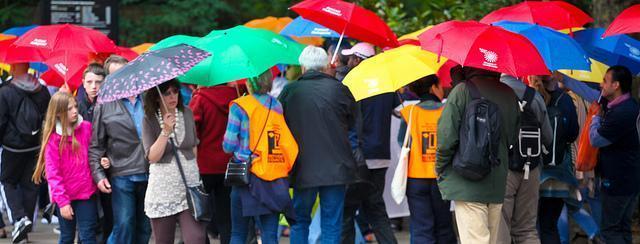How many umbrellas can you see?
Give a very brief answer. 8. How many people are there?
Give a very brief answer. 12. How many backpacks are there?
Give a very brief answer. 2. How many oranges can you see?
Give a very brief answer. 0. 